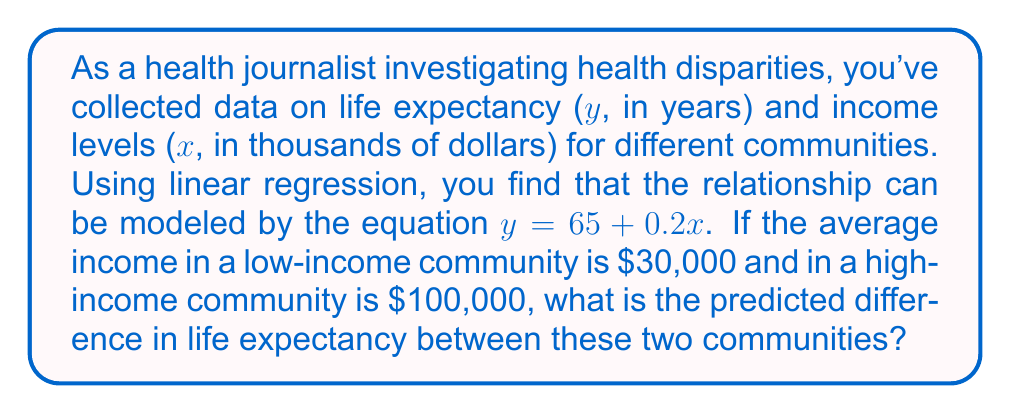Solve this math problem. To solve this problem, we'll follow these steps:

1) We have the linear regression equation: $y = 65 + 0.2x$
   Where y is life expectancy in years and x is income in thousands of dollars.

2) For the low-income community:
   x = 30 (as $30,000 = 30 thousand dollars)
   $y_{low} = 65 + 0.2(30)$
   $y_{low} = 65 + 6 = 71$ years

3) For the high-income community:
   x = 100 (as $100,000 = 100 thousand dollars)
   $y_{high} = 65 + 0.2(100)$
   $y_{high} = 65 + 20 = 85$ years

4) The difference in life expectancy:
   $\Delta y = y_{high} - y_{low}$
   $\Delta y = 85 - 71 = 14$ years

Therefore, the predicted difference in life expectancy between the high-income and low-income communities is 14 years.
Answer: 14 years 